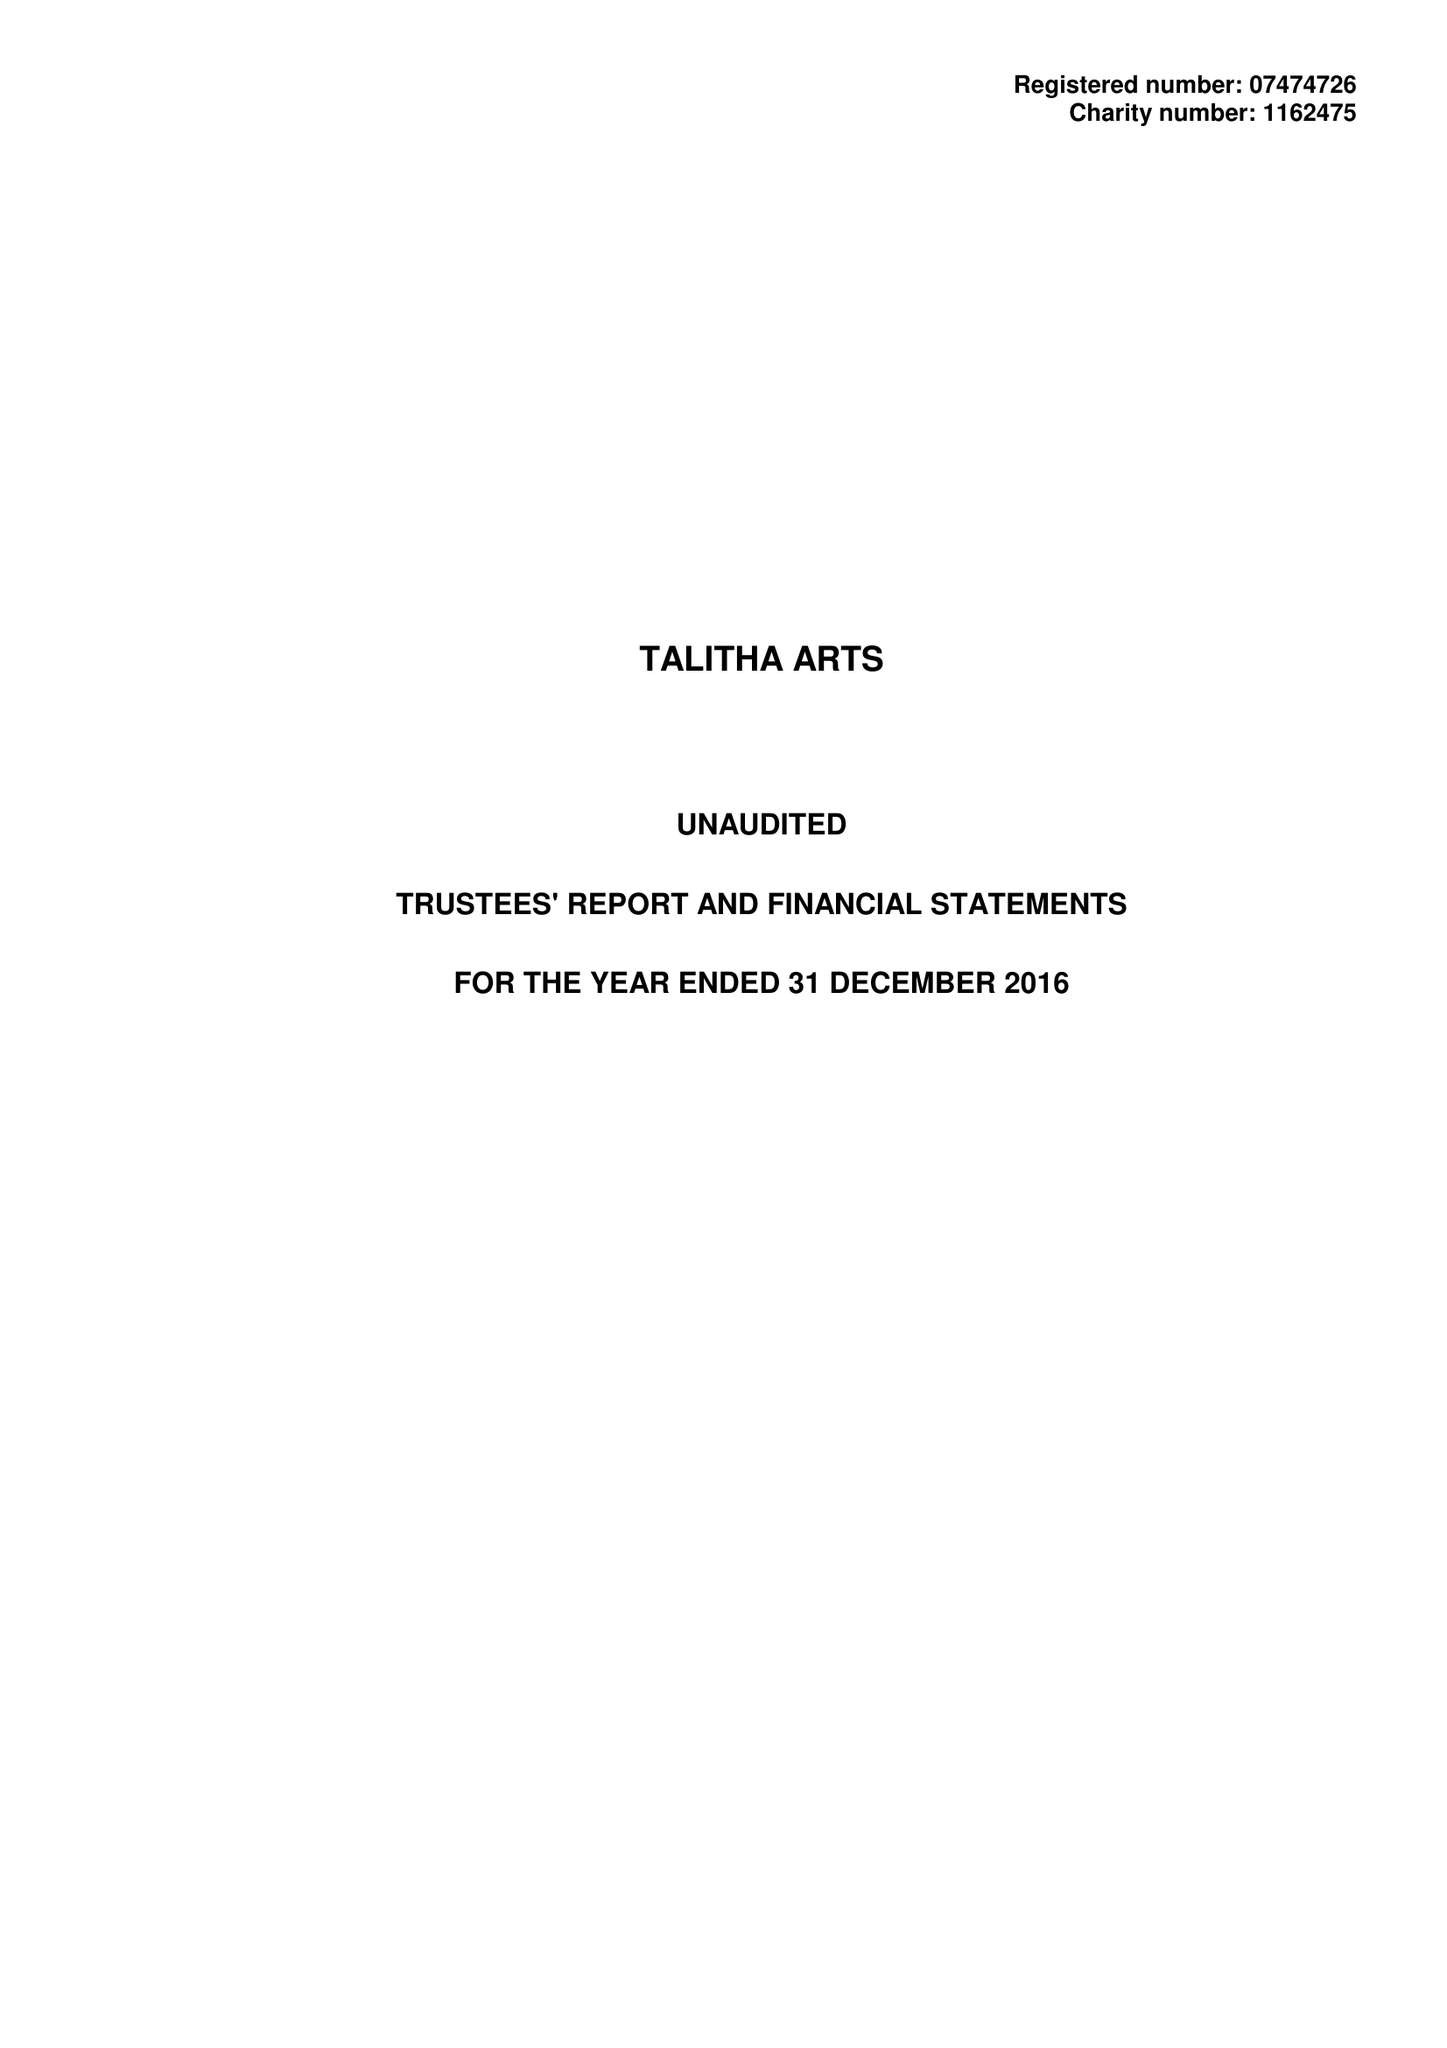What is the value for the report_date?
Answer the question using a single word or phrase. 2016-12-31 